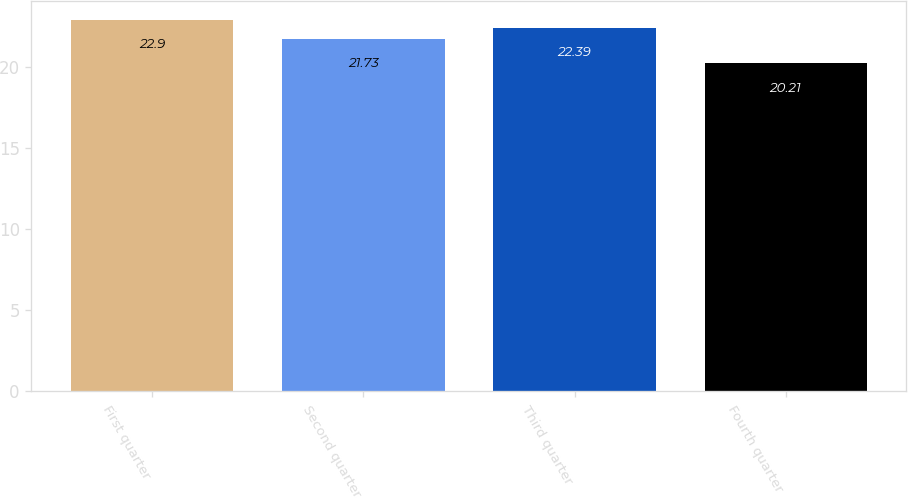Convert chart. <chart><loc_0><loc_0><loc_500><loc_500><bar_chart><fcel>First quarter<fcel>Second quarter<fcel>Third quarter<fcel>Fourth quarter<nl><fcel>22.9<fcel>21.73<fcel>22.39<fcel>20.21<nl></chart> 